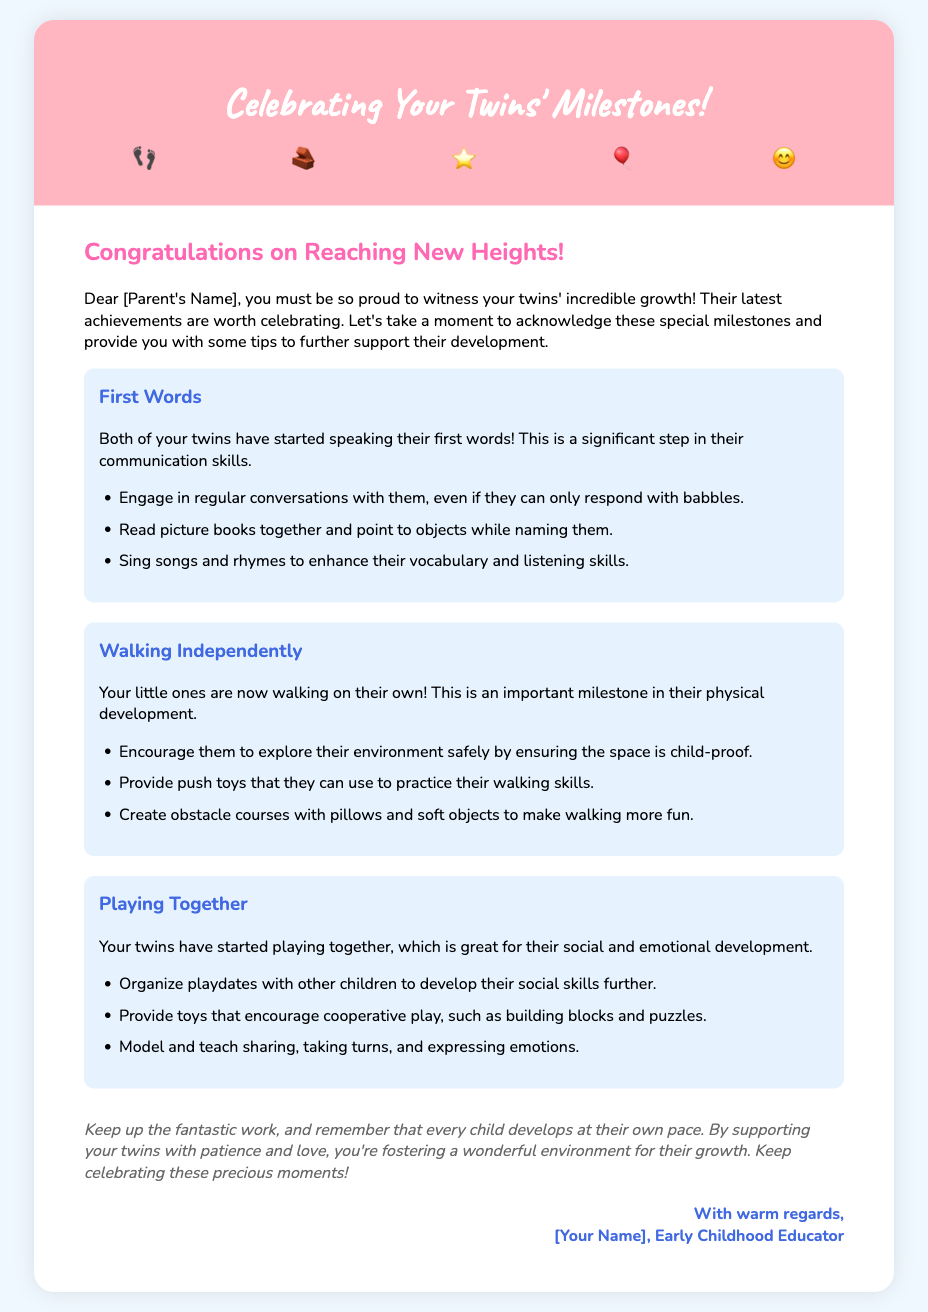What is the title of the card? The title is prominently displayed at the top of the card to indicate the main theme.
Answer: Celebrating Your Twins' Milestones! How many milestone icons are shown in the card? The card features a container displaying several milestone icons at the top.
Answer: Five What significant achievement is mentioned first in the milestones? The list of milestones includes several achievements, with the first one highlighted as significant.
Answer: First Words What activity is suggested to enhance vocabulary? The suggestions for supporting development include specific activities for each milestone achievement.
Answer: Read picture books together What is one benefit of twins playing together? The document highlights the developmental advantages of twins engaging in play.
Answer: Social and emotional development What color is used for the card title? The color of the card title is specified in the style section of the document.
Answer: White Who is the card addressed to? The greeting uses a personal salutation, indicating the recipient.
Answer: [Parent's Name] What type of educator signed off the card? The closing section mentions the profession of the author of the card.
Answer: Early Childhood Educator 